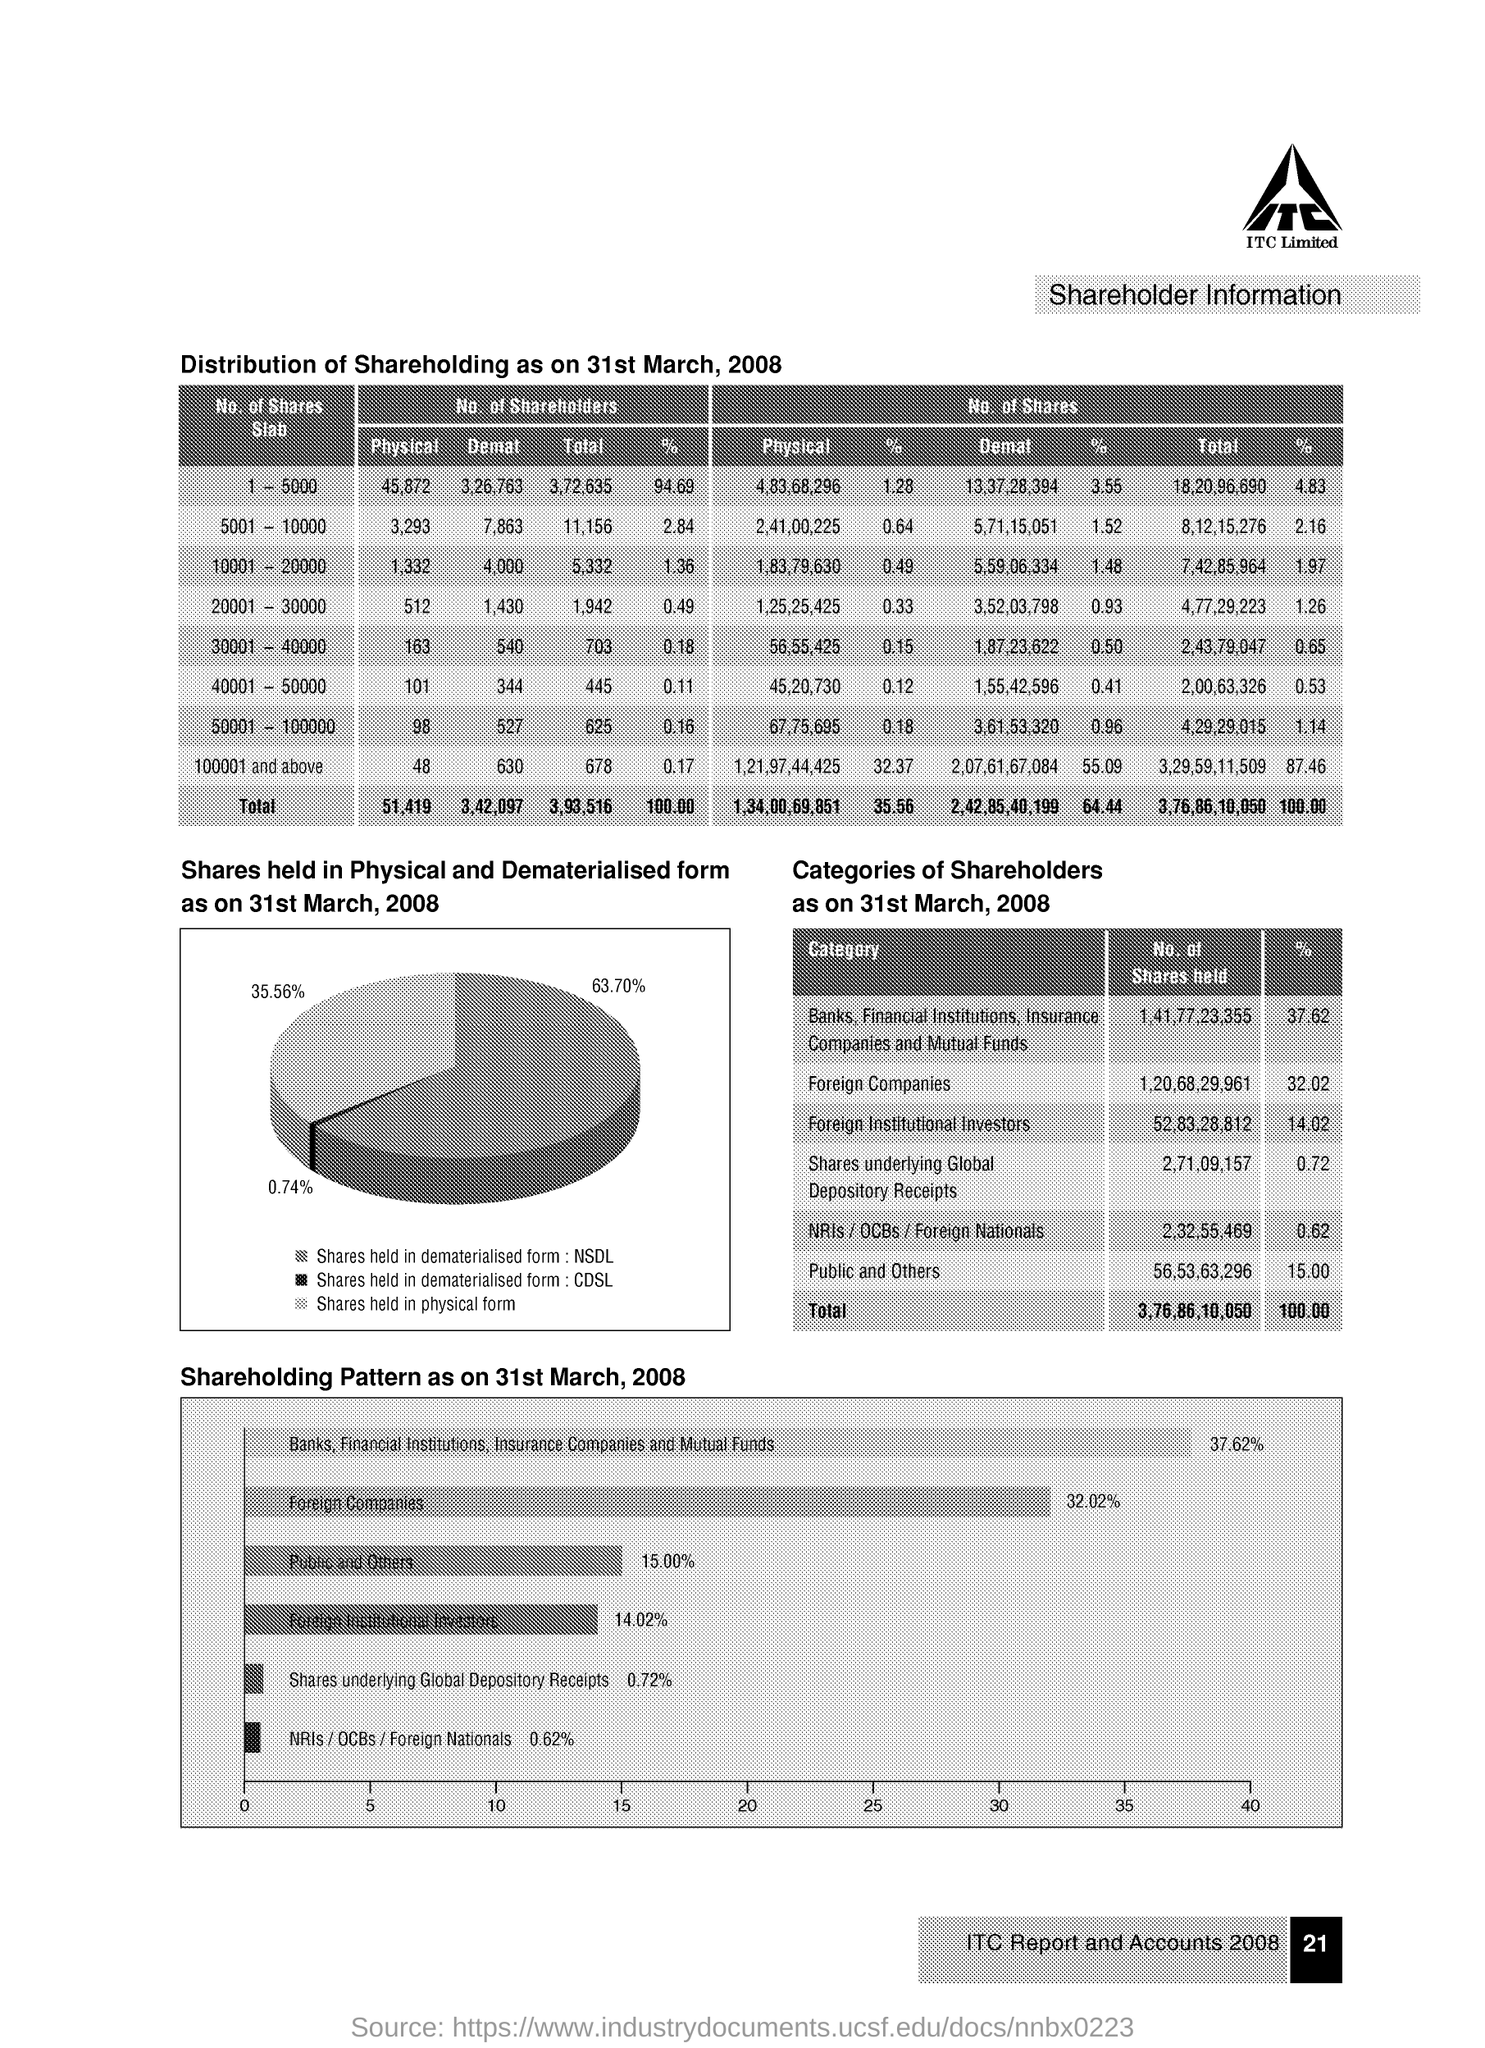Mention a couple of crucial points in this snapshot. The total number of shares is 3,76,86,10,050. The number of shareholders in the 1-5000 slab is 3,72,635. There are 56,55,425 physical shares in the range of 30,001 to 40,000. Approximately 32.02% of the shares listed on the Stock Exchange are held by foreign companies. 